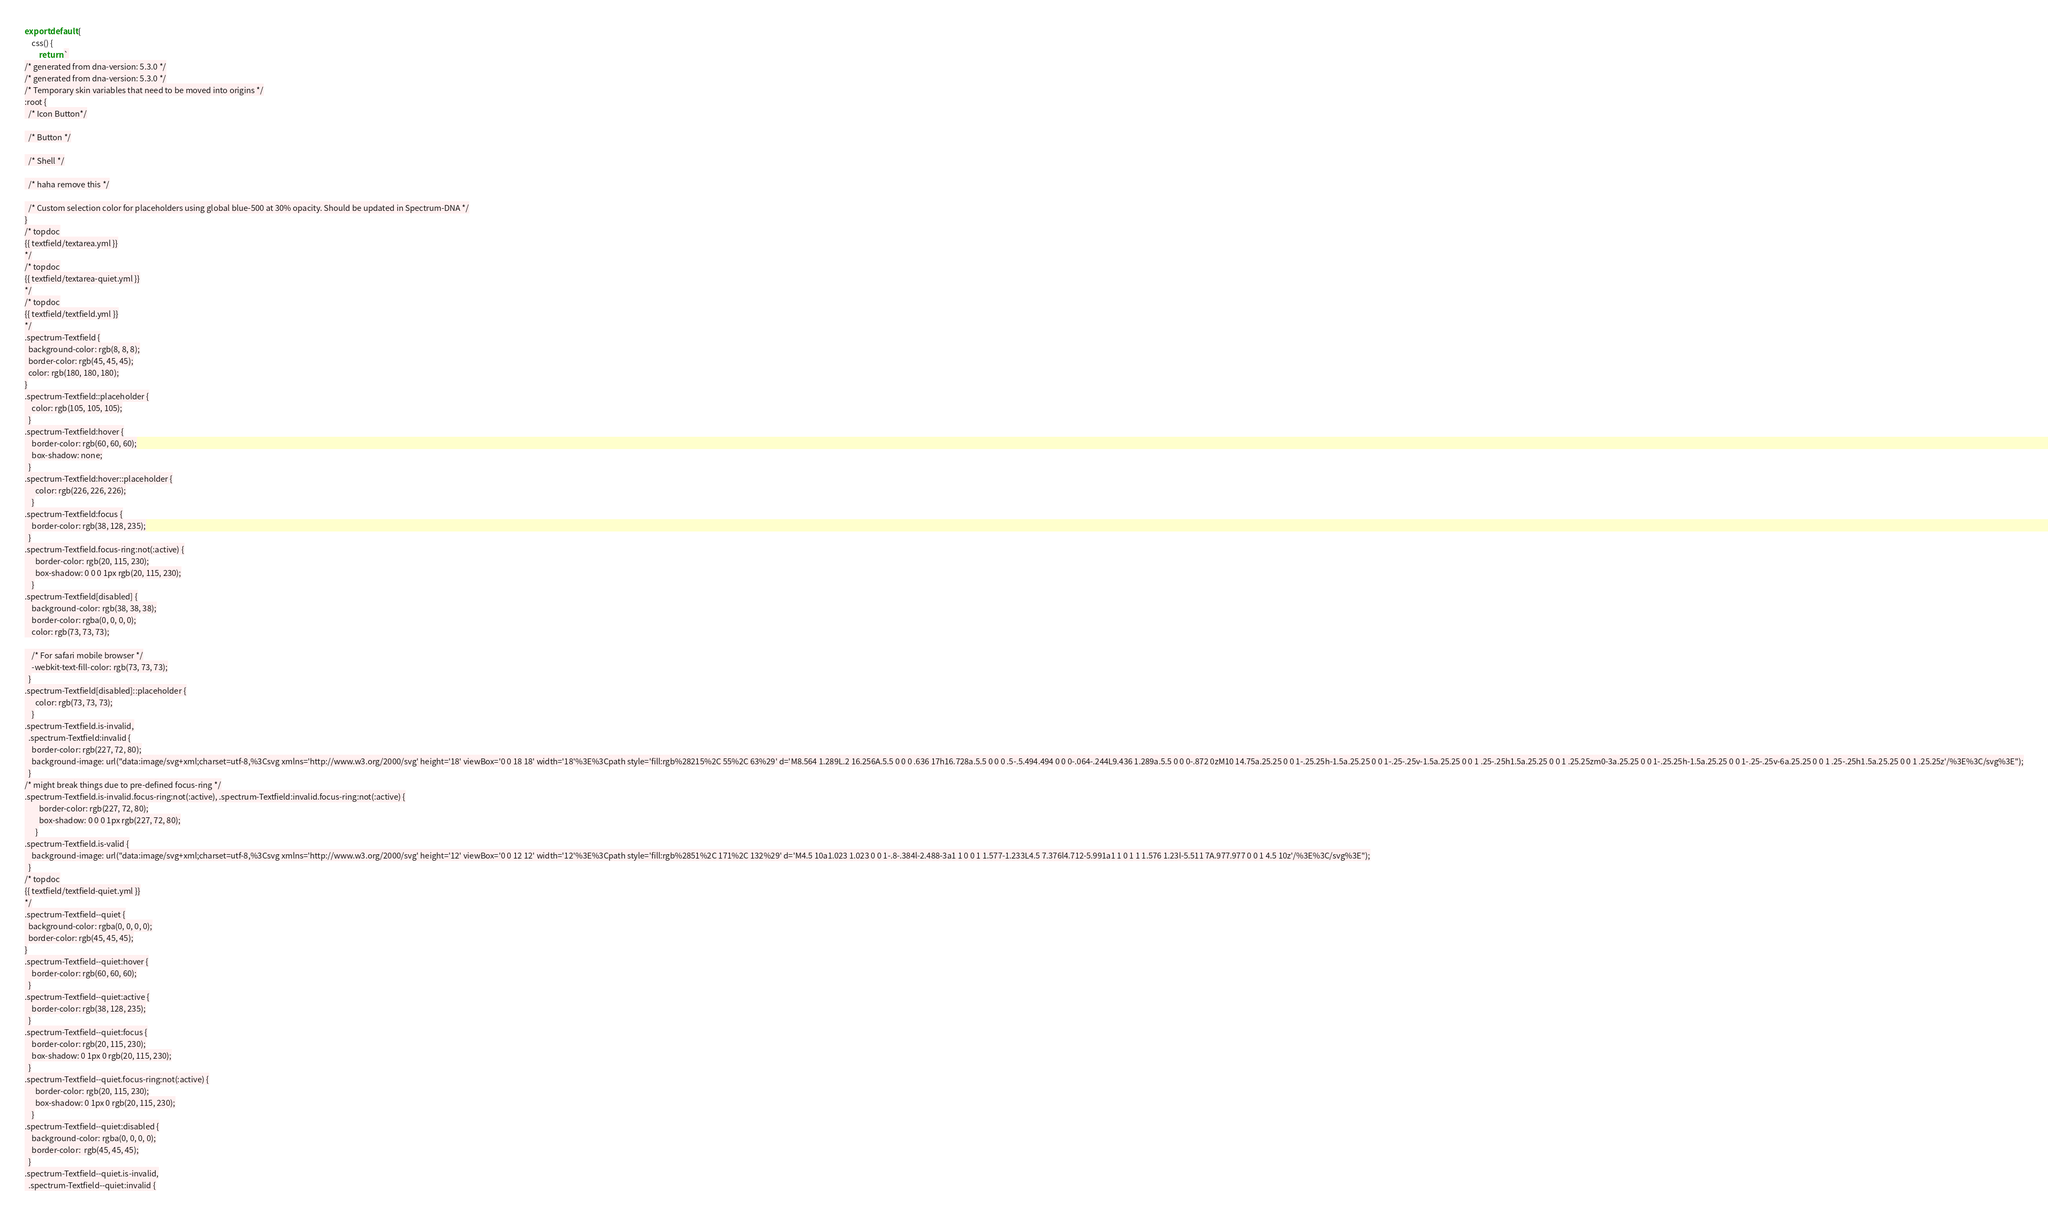Convert code to text. <code><loc_0><loc_0><loc_500><loc_500><_JavaScript_>export default { 
    css() {
        return `
/* generated from dna-version: 5.3.0 */
/* generated from dna-version: 5.3.0 */
/* Temporary skin variables that need to be moved into origins */
:root {
  /* Icon Button*/

  /* Button */

  /* Shell */

  /* haha remove this */

  /* Custom selection color for placeholders using global blue-500 at 30% opacity. Should be updated in Spectrum-DNA */
}
/* topdoc
{{ textfield/textarea.yml }}
*/
/* topdoc
{{ textfield/textarea-quiet.yml }}
*/
/* topdoc
{{ textfield/textfield.yml }}
*/
.spectrum-Textfield {
  background-color: rgb(8, 8, 8);
  border-color: rgb(45, 45, 45);
  color: rgb(180, 180, 180);
}
.spectrum-Textfield::placeholder {
    color: rgb(105, 105, 105);
  }
.spectrum-Textfield:hover {
    border-color: rgb(60, 60, 60);
    box-shadow: none;
  }
.spectrum-Textfield:hover::placeholder {
      color: rgb(226, 226, 226);
    }
.spectrum-Textfield:focus {
    border-color: rgb(38, 128, 235);
  }
.spectrum-Textfield.focus-ring:not(:active) {
      border-color: rgb(20, 115, 230);
      box-shadow: 0 0 0 1px rgb(20, 115, 230);
    }
.spectrum-Textfield[disabled] {
    background-color: rgb(38, 38, 38);
    border-color: rgba(0, 0, 0, 0);
    color: rgb(73, 73, 73);

    /* For safari mobile browser */
    -webkit-text-fill-color: rgb(73, 73, 73);
  }
.spectrum-Textfield[disabled]::placeholder {
      color: rgb(73, 73, 73);
    }
.spectrum-Textfield.is-invalid,
  .spectrum-Textfield:invalid {
    border-color: rgb(227, 72, 80);
    background-image: url("data:image/svg+xml;charset=utf-8,%3Csvg xmlns='http://www.w3.org/2000/svg' height='18' viewBox='0 0 18 18' width='18'%3E%3Cpath style='fill:rgb%28215%2C 55%2C 63%29' d='M8.564 1.289L.2 16.256A.5.5 0 0 0 .636 17h16.728a.5.5 0 0 0 .5-.5.494.494 0 0 0-.064-.244L9.436 1.289a.5.5 0 0 0-.872 0zM10 14.75a.25.25 0 0 1-.25.25h-1.5a.25.25 0 0 1-.25-.25v-1.5a.25.25 0 0 1 .25-.25h1.5a.25.25 0 0 1 .25.25zm0-3a.25.25 0 0 1-.25.25h-1.5a.25.25 0 0 1-.25-.25v-6a.25.25 0 0 1 .25-.25h1.5a.25.25 0 0 1 .25.25z'/%3E%3C/svg%3E");
  }
/* might break things due to pre-defined focus-ring */
.spectrum-Textfield.is-invalid.focus-ring:not(:active), .spectrum-Textfield:invalid.focus-ring:not(:active) {
        border-color: rgb(227, 72, 80);
        box-shadow: 0 0 0 1px rgb(227, 72, 80);
      }
.spectrum-Textfield.is-valid {
    background-image: url("data:image/svg+xml;charset=utf-8,%3Csvg xmlns='http://www.w3.org/2000/svg' height='12' viewBox='0 0 12 12' width='12'%3E%3Cpath style='fill:rgb%2851%2C 171%2C 132%29' d='M4.5 10a1.023 1.023 0 0 1-.8-.384l-2.488-3a1 1 0 0 1 1.577-1.233L4.5 7.376l4.712-5.991a1 1 0 1 1 1.576 1.23l-5.511 7A.977.977 0 0 1 4.5 10z'/%3E%3C/svg%3E");
  }
/* topdoc
{{ textfield/textfield-quiet.yml }}
*/
.spectrum-Textfield--quiet {
  background-color: rgba(0, 0, 0, 0);
  border-color: rgb(45, 45, 45);
}
.spectrum-Textfield--quiet:hover {
    border-color: rgb(60, 60, 60);
  }
.spectrum-Textfield--quiet:active {
    border-color: rgb(38, 128, 235);
  }
.spectrum-Textfield--quiet:focus {
    border-color: rgb(20, 115, 230);
    box-shadow: 0 1px 0 rgb(20, 115, 230);
  }
.spectrum-Textfield--quiet.focus-ring:not(:active) {
      border-color: rgb(20, 115, 230);
      box-shadow: 0 1px 0 rgb(20, 115, 230);
    }
.spectrum-Textfield--quiet:disabled {
    background-color: rgba(0, 0, 0, 0);
    border-color:  rgb(45, 45, 45);
  }
.spectrum-Textfield--quiet.is-invalid,
  .spectrum-Textfield--quiet:invalid {</code> 